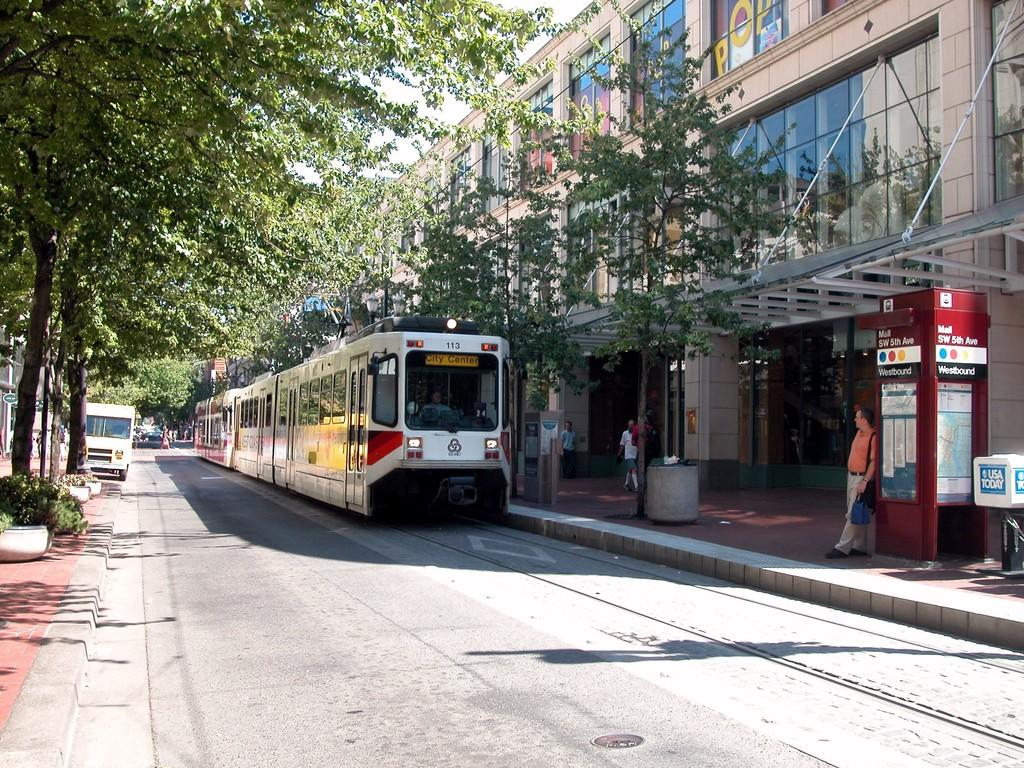What is the main mode of transportation in the image? There is a train in the image, which is a mode of transportation. What is the train traveling on? There is a railway track in the image, which the train is traveling on. What other vehicle is present in the image? There is a truck in the image. What type of natural environment can be seen in the image? There are trees in the image. What type of man-made structures can be seen in the image? There are buildings in the image. Are there any people visible in the image? Yes, there are people in the image. What is visible at the top of the image? The sky is visible at the top of the image. What type of humor can be seen in the image? There is no humor present in the image; it is a scene featuring a train, railway track, truck, trees, buildings, people, and sky. 